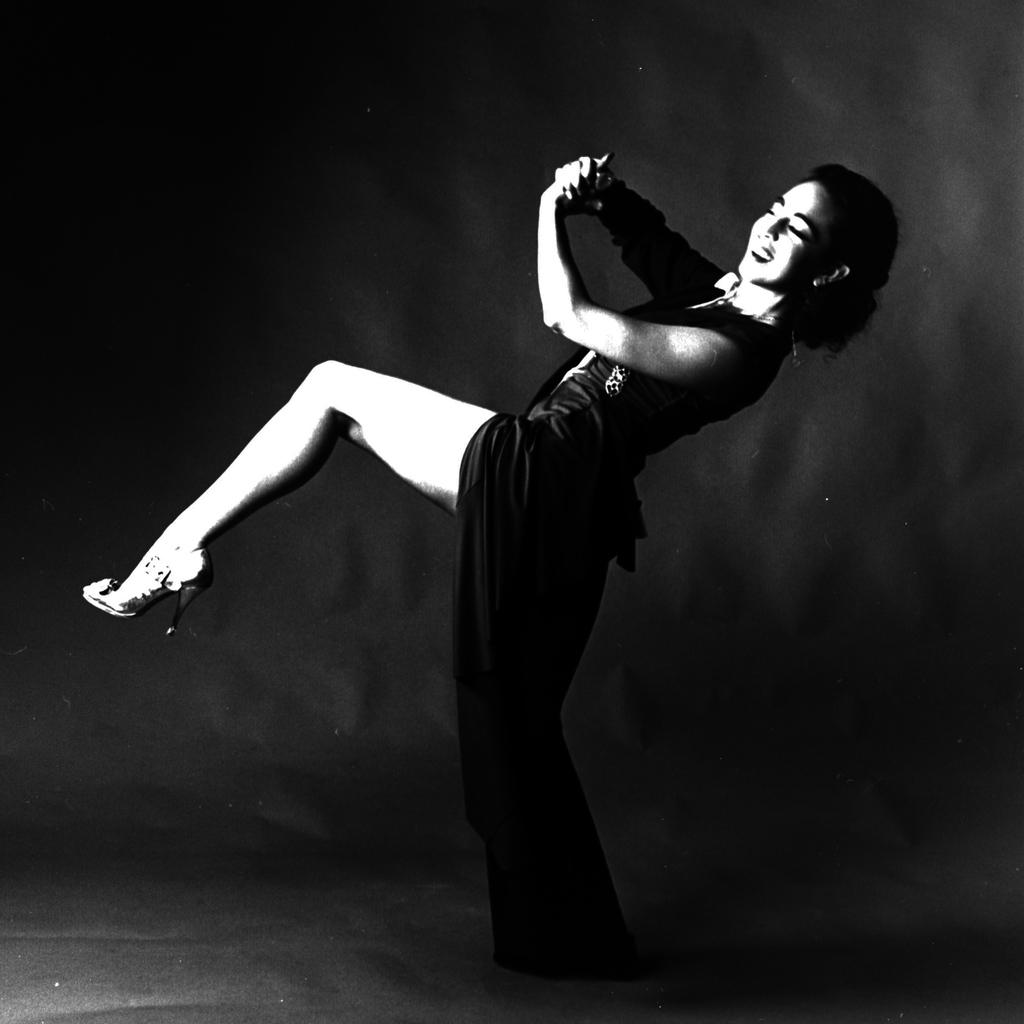What is the color scheme of the image? The image is black and white. Who is present in the image? There is a woman in the image. What is the woman's expression in the image? The woman is smiling in the image. What can be seen in the background of the image? The background of the image is dark. Where are the dolls playing with the powder in the image? There are no dolls or powder present in the image. 